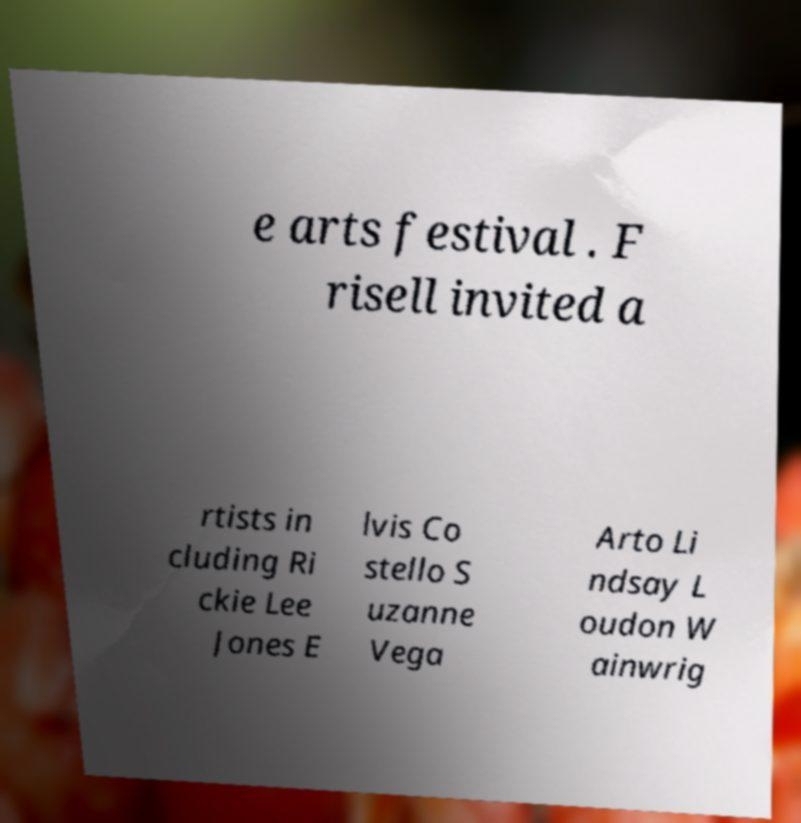Can you accurately transcribe the text from the provided image for me? e arts festival . F risell invited a rtists in cluding Ri ckie Lee Jones E lvis Co stello S uzanne Vega Arto Li ndsay L oudon W ainwrig 